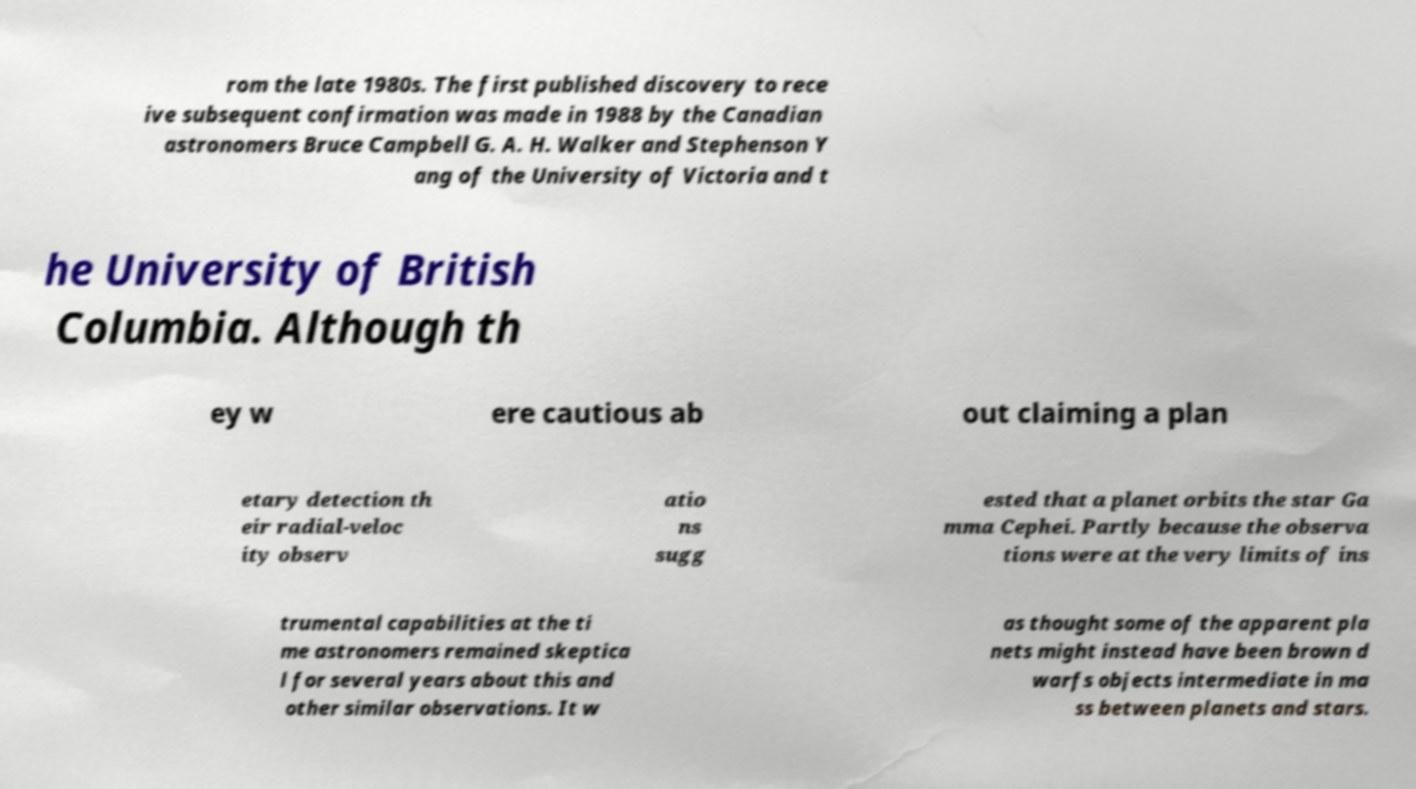I need the written content from this picture converted into text. Can you do that? rom the late 1980s. The first published discovery to rece ive subsequent confirmation was made in 1988 by the Canadian astronomers Bruce Campbell G. A. H. Walker and Stephenson Y ang of the University of Victoria and t he University of British Columbia. Although th ey w ere cautious ab out claiming a plan etary detection th eir radial-veloc ity observ atio ns sugg ested that a planet orbits the star Ga mma Cephei. Partly because the observa tions were at the very limits of ins trumental capabilities at the ti me astronomers remained skeptica l for several years about this and other similar observations. It w as thought some of the apparent pla nets might instead have been brown d warfs objects intermediate in ma ss between planets and stars. 